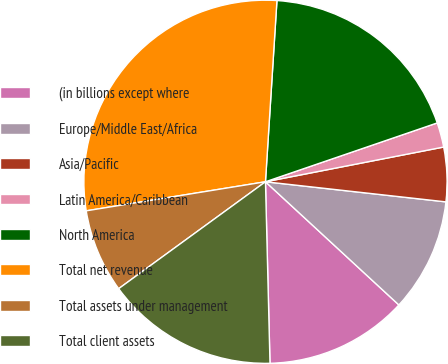Convert chart. <chart><loc_0><loc_0><loc_500><loc_500><pie_chart><fcel>(in billions except where<fcel>Europe/Middle East/Africa<fcel>Asia/Pacific<fcel>Latin America/Caribbean<fcel>North America<fcel>Total net revenue<fcel>Total assets under management<fcel>Total client assets<nl><fcel>12.74%<fcel>10.1%<fcel>4.83%<fcel>2.19%<fcel>18.74%<fcel>28.57%<fcel>7.46%<fcel>15.38%<nl></chart> 